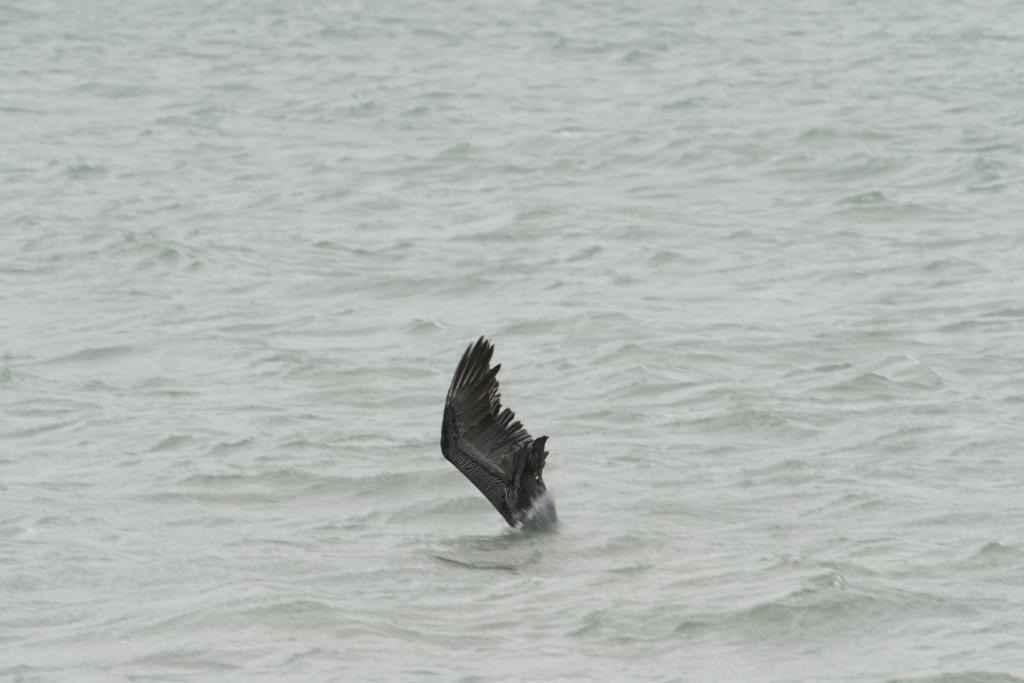Please provide a concise description of this image. In this picture there is a bird which is touching the water. At the top I can see the river or ocean. 